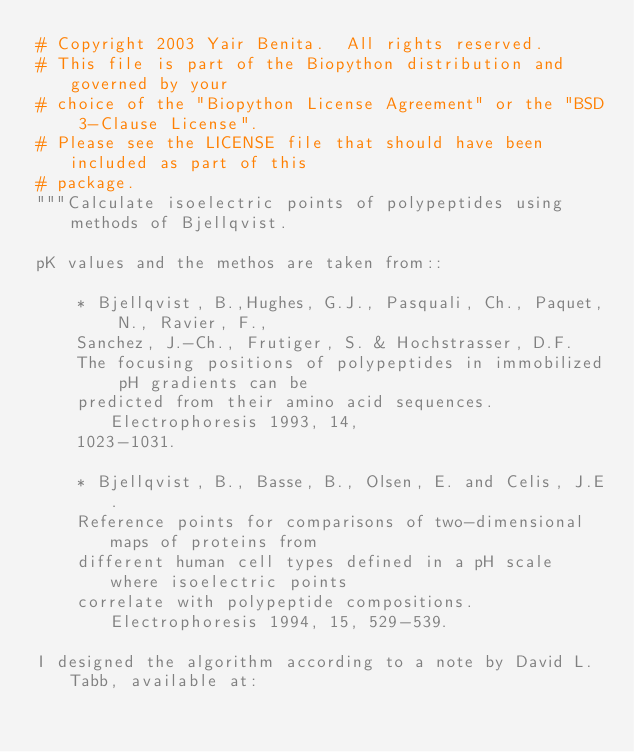Convert code to text. <code><loc_0><loc_0><loc_500><loc_500><_Python_># Copyright 2003 Yair Benita.  All rights reserved.
# This file is part of the Biopython distribution and governed by your
# choice of the "Biopython License Agreement" or the "BSD 3-Clause License".
# Please see the LICENSE file that should have been included as part of this
# package.
"""Calculate isoelectric points of polypeptides using methods of Bjellqvist.

pK values and the methos are taken from::

    * Bjellqvist, B.,Hughes, G.J., Pasquali, Ch., Paquet, N., Ravier, F.,
    Sanchez, J.-Ch., Frutiger, S. & Hochstrasser, D.F.
    The focusing positions of polypeptides in immobilized pH gradients can be
    predicted from their amino acid sequences. Electrophoresis 1993, 14,
    1023-1031.

    * Bjellqvist, B., Basse, B., Olsen, E. and Celis, J.E.
    Reference points for comparisons of two-dimensional maps of proteins from
    different human cell types defined in a pH scale where isoelectric points
    correlate with polypeptide compositions. Electrophoresis 1994, 15, 529-539.

I designed the algorithm according to a note by David L. Tabb, available at:</code> 